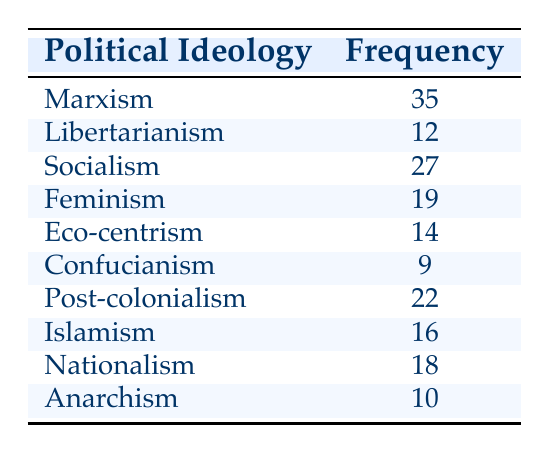What is the frequency of Marxism in academic publications? The table directly states the frequency of Marxism, which is listed as 35.
Answer: 35 Which political ideology has the lowest frequency? Looking at the frequencies listed, Confucianism has the lowest frequency at 9.
Answer: Confucianism What is the total frequency of Socialism and Feminism combined? The frequency of Socialism is 27, and the frequency of Feminism is 19. Summing these gives 27 + 19 = 46.
Answer: 46 Is the frequency of Post-colonialism greater than that of Eco-centrism? The frequency of Post-colonialism is 22, while Eco-centrism has a frequency of 14. Since 22 is greater than 14, the statement is true.
Answer: Yes What is the median frequency of the political ideologies listed? To find the median, we must first list the frequencies in ascending order: 9, 10, 12, 14, 16, 18, 19, 22, 27, 35. There are 10 numbers, so the median will be the average of the 5th (16) and 6th (18) values: (16 + 18) / 2 = 17.
Answer: 17 What is the difference in frequency between Nationalism and Anarchism? The frequency of Nationalism is 18 and that of Anarchism is 10. The difference is calculated as 18 - 10 = 8.
Answer: 8 Does the total frequency of Feminism and Islamism exceed 35? The frequency of Feminism is 19, and that of Islamism is 16. Their total is 19 + 16 = 35, which does not exceed 35, so the statement is false.
Answer: No How many political ideologies have a frequency higher than 15? By examining the table, the ideologies with frequencies greater than 15 are Marxism (35), Socialism (27), Feminism (19), Post-colonialism (22), Islamism (16), and Nationalism (18). This totals to 6 ideologies.
Answer: 6 Which political ideology has a frequency that is 50% higher than that of Libertarianism? The frequency of Libertarianism is 12. A frequency that is 50% higher would be 12 + (12 * 0.5) = 18. The ideologies with frequencies of 18 or higher are Nationalism (18), Islamism (16), Post-colonialism (22), Socialist (27), and Marxism (35). Since Nationalism is the only ideology at exactly 18, that is the answer.
Answer: Nationalism 